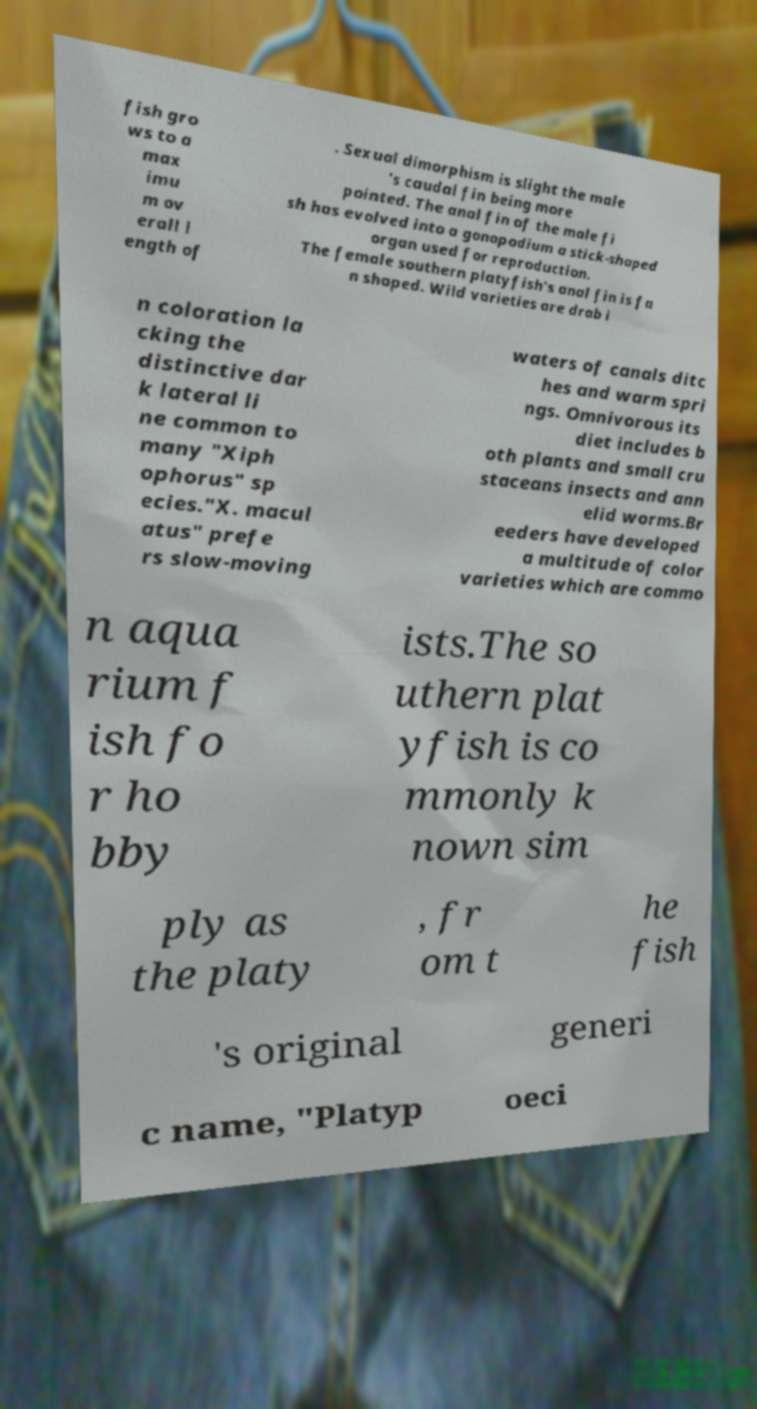Can you accurately transcribe the text from the provided image for me? fish gro ws to a max imu m ov erall l ength of . Sexual dimorphism is slight the male 's caudal fin being more pointed. The anal fin of the male fi sh has evolved into a gonopodium a stick-shaped organ used for reproduction. The female southern platyfish's anal fin is fa n shaped. Wild varieties are drab i n coloration la cking the distinctive dar k lateral li ne common to many "Xiph ophorus" sp ecies."X. macul atus" prefe rs slow-moving waters of canals ditc hes and warm spri ngs. Omnivorous its diet includes b oth plants and small cru staceans insects and ann elid worms.Br eeders have developed a multitude of color varieties which are commo n aqua rium f ish fo r ho bby ists.The so uthern plat yfish is co mmonly k nown sim ply as the platy , fr om t he fish 's original generi c name, "Platyp oeci 